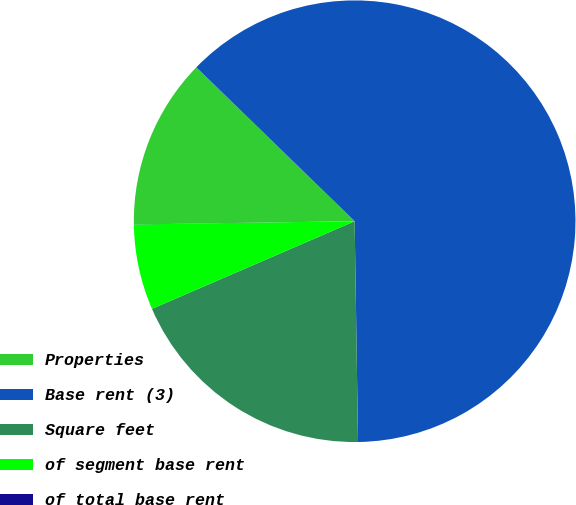Convert chart. <chart><loc_0><loc_0><loc_500><loc_500><pie_chart><fcel>Properties<fcel>Base rent (3)<fcel>Square feet<fcel>of segment base rent<fcel>of total base rent<nl><fcel>12.5%<fcel>62.48%<fcel>18.75%<fcel>6.26%<fcel>0.01%<nl></chart> 